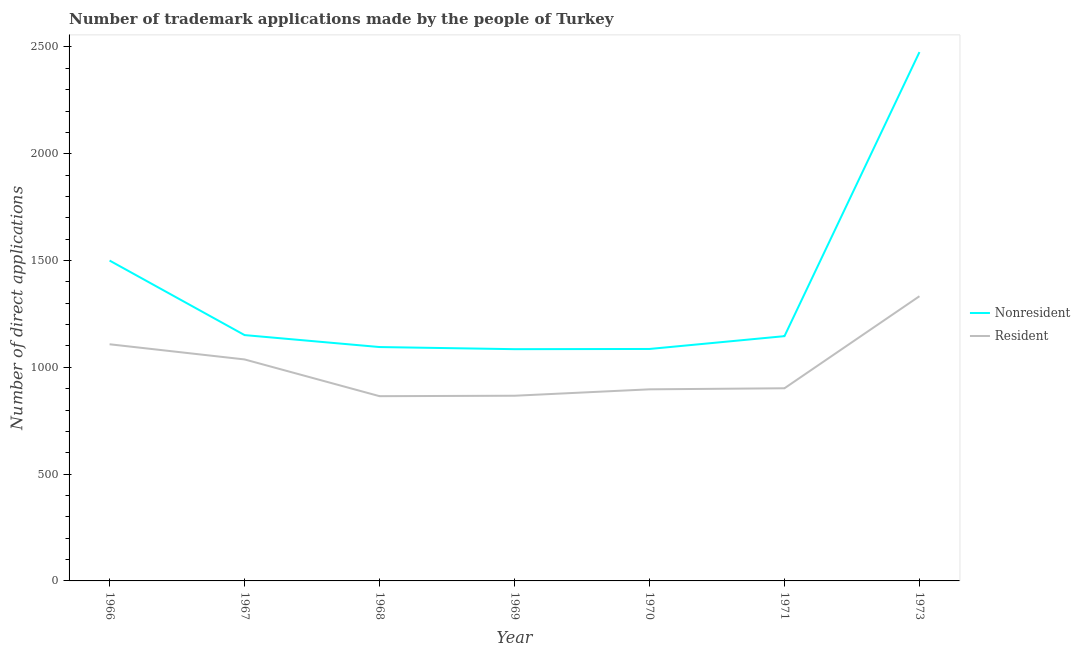How many different coloured lines are there?
Your response must be concise. 2. Does the line corresponding to number of trademark applications made by residents intersect with the line corresponding to number of trademark applications made by non residents?
Provide a succinct answer. No. What is the number of trademark applications made by residents in 1967?
Provide a short and direct response. 1037. Across all years, what is the maximum number of trademark applications made by non residents?
Keep it short and to the point. 2476. Across all years, what is the minimum number of trademark applications made by residents?
Offer a very short reply. 865. In which year was the number of trademark applications made by residents maximum?
Make the answer very short. 1973. In which year was the number of trademark applications made by non residents minimum?
Keep it short and to the point. 1969. What is the total number of trademark applications made by residents in the graph?
Make the answer very short. 7009. What is the difference between the number of trademark applications made by residents in 1967 and that in 1968?
Ensure brevity in your answer.  172. What is the difference between the number of trademark applications made by residents in 1967 and the number of trademark applications made by non residents in 1973?
Make the answer very short. -1439. What is the average number of trademark applications made by non residents per year?
Keep it short and to the point. 1362.71. In the year 1969, what is the difference between the number of trademark applications made by non residents and number of trademark applications made by residents?
Keep it short and to the point. 218. In how many years, is the number of trademark applications made by residents greater than 500?
Your answer should be compact. 7. What is the ratio of the number of trademark applications made by non residents in 1967 to that in 1973?
Give a very brief answer. 0.46. Is the number of trademark applications made by non residents in 1968 less than that in 1971?
Provide a short and direct response. Yes. What is the difference between the highest and the second highest number of trademark applications made by residents?
Offer a very short reply. 225. What is the difference between the highest and the lowest number of trademark applications made by non residents?
Offer a very short reply. 1391. In how many years, is the number of trademark applications made by residents greater than the average number of trademark applications made by residents taken over all years?
Provide a succinct answer. 3. Is the sum of the number of trademark applications made by residents in 1969 and 1973 greater than the maximum number of trademark applications made by non residents across all years?
Make the answer very short. No. Is the number of trademark applications made by residents strictly greater than the number of trademark applications made by non residents over the years?
Ensure brevity in your answer.  No. How many years are there in the graph?
Keep it short and to the point. 7. What is the difference between two consecutive major ticks on the Y-axis?
Keep it short and to the point. 500. Does the graph contain grids?
Your answer should be very brief. No. Where does the legend appear in the graph?
Your answer should be very brief. Center right. How many legend labels are there?
Offer a terse response. 2. How are the legend labels stacked?
Make the answer very short. Vertical. What is the title of the graph?
Your response must be concise. Number of trademark applications made by the people of Turkey. What is the label or title of the X-axis?
Provide a short and direct response. Year. What is the label or title of the Y-axis?
Offer a very short reply. Number of direct applications. What is the Number of direct applications of Nonresident in 1966?
Provide a succinct answer. 1500. What is the Number of direct applications of Resident in 1966?
Provide a short and direct response. 1108. What is the Number of direct applications of Nonresident in 1967?
Ensure brevity in your answer.  1151. What is the Number of direct applications of Resident in 1967?
Offer a very short reply. 1037. What is the Number of direct applications in Nonresident in 1968?
Provide a succinct answer. 1095. What is the Number of direct applications of Resident in 1968?
Offer a very short reply. 865. What is the Number of direct applications in Nonresident in 1969?
Offer a very short reply. 1085. What is the Number of direct applications of Resident in 1969?
Offer a terse response. 867. What is the Number of direct applications in Nonresident in 1970?
Offer a terse response. 1086. What is the Number of direct applications of Resident in 1970?
Make the answer very short. 897. What is the Number of direct applications in Nonresident in 1971?
Ensure brevity in your answer.  1146. What is the Number of direct applications in Resident in 1971?
Keep it short and to the point. 902. What is the Number of direct applications of Nonresident in 1973?
Provide a short and direct response. 2476. What is the Number of direct applications in Resident in 1973?
Offer a terse response. 1333. Across all years, what is the maximum Number of direct applications in Nonresident?
Provide a succinct answer. 2476. Across all years, what is the maximum Number of direct applications in Resident?
Provide a short and direct response. 1333. Across all years, what is the minimum Number of direct applications in Nonresident?
Your answer should be very brief. 1085. Across all years, what is the minimum Number of direct applications in Resident?
Offer a terse response. 865. What is the total Number of direct applications of Nonresident in the graph?
Provide a short and direct response. 9539. What is the total Number of direct applications of Resident in the graph?
Offer a very short reply. 7009. What is the difference between the Number of direct applications in Nonresident in 1966 and that in 1967?
Make the answer very short. 349. What is the difference between the Number of direct applications in Nonresident in 1966 and that in 1968?
Your answer should be compact. 405. What is the difference between the Number of direct applications in Resident in 1966 and that in 1968?
Keep it short and to the point. 243. What is the difference between the Number of direct applications of Nonresident in 1966 and that in 1969?
Offer a terse response. 415. What is the difference between the Number of direct applications in Resident in 1966 and that in 1969?
Provide a succinct answer. 241. What is the difference between the Number of direct applications of Nonresident in 1966 and that in 1970?
Offer a very short reply. 414. What is the difference between the Number of direct applications of Resident in 1966 and that in 1970?
Make the answer very short. 211. What is the difference between the Number of direct applications of Nonresident in 1966 and that in 1971?
Ensure brevity in your answer.  354. What is the difference between the Number of direct applications in Resident in 1966 and that in 1971?
Your response must be concise. 206. What is the difference between the Number of direct applications of Nonresident in 1966 and that in 1973?
Provide a short and direct response. -976. What is the difference between the Number of direct applications of Resident in 1966 and that in 1973?
Keep it short and to the point. -225. What is the difference between the Number of direct applications in Nonresident in 1967 and that in 1968?
Offer a terse response. 56. What is the difference between the Number of direct applications in Resident in 1967 and that in 1968?
Offer a very short reply. 172. What is the difference between the Number of direct applications of Nonresident in 1967 and that in 1969?
Keep it short and to the point. 66. What is the difference between the Number of direct applications in Resident in 1967 and that in 1969?
Offer a very short reply. 170. What is the difference between the Number of direct applications of Resident in 1967 and that in 1970?
Offer a terse response. 140. What is the difference between the Number of direct applications of Nonresident in 1967 and that in 1971?
Provide a succinct answer. 5. What is the difference between the Number of direct applications of Resident in 1967 and that in 1971?
Make the answer very short. 135. What is the difference between the Number of direct applications in Nonresident in 1967 and that in 1973?
Your response must be concise. -1325. What is the difference between the Number of direct applications of Resident in 1967 and that in 1973?
Provide a succinct answer. -296. What is the difference between the Number of direct applications in Nonresident in 1968 and that in 1970?
Ensure brevity in your answer.  9. What is the difference between the Number of direct applications of Resident in 1968 and that in 1970?
Your answer should be very brief. -32. What is the difference between the Number of direct applications of Nonresident in 1968 and that in 1971?
Give a very brief answer. -51. What is the difference between the Number of direct applications of Resident in 1968 and that in 1971?
Ensure brevity in your answer.  -37. What is the difference between the Number of direct applications of Nonresident in 1968 and that in 1973?
Ensure brevity in your answer.  -1381. What is the difference between the Number of direct applications of Resident in 1968 and that in 1973?
Provide a succinct answer. -468. What is the difference between the Number of direct applications in Resident in 1969 and that in 1970?
Your response must be concise. -30. What is the difference between the Number of direct applications of Nonresident in 1969 and that in 1971?
Give a very brief answer. -61. What is the difference between the Number of direct applications of Resident in 1969 and that in 1971?
Ensure brevity in your answer.  -35. What is the difference between the Number of direct applications in Nonresident in 1969 and that in 1973?
Make the answer very short. -1391. What is the difference between the Number of direct applications of Resident in 1969 and that in 1973?
Provide a succinct answer. -466. What is the difference between the Number of direct applications in Nonresident in 1970 and that in 1971?
Offer a terse response. -60. What is the difference between the Number of direct applications in Resident in 1970 and that in 1971?
Ensure brevity in your answer.  -5. What is the difference between the Number of direct applications of Nonresident in 1970 and that in 1973?
Provide a succinct answer. -1390. What is the difference between the Number of direct applications of Resident in 1970 and that in 1973?
Your response must be concise. -436. What is the difference between the Number of direct applications in Nonresident in 1971 and that in 1973?
Provide a succinct answer. -1330. What is the difference between the Number of direct applications in Resident in 1971 and that in 1973?
Offer a very short reply. -431. What is the difference between the Number of direct applications of Nonresident in 1966 and the Number of direct applications of Resident in 1967?
Offer a terse response. 463. What is the difference between the Number of direct applications in Nonresident in 1966 and the Number of direct applications in Resident in 1968?
Offer a terse response. 635. What is the difference between the Number of direct applications of Nonresident in 1966 and the Number of direct applications of Resident in 1969?
Provide a succinct answer. 633. What is the difference between the Number of direct applications in Nonresident in 1966 and the Number of direct applications in Resident in 1970?
Your answer should be compact. 603. What is the difference between the Number of direct applications of Nonresident in 1966 and the Number of direct applications of Resident in 1971?
Offer a very short reply. 598. What is the difference between the Number of direct applications in Nonresident in 1966 and the Number of direct applications in Resident in 1973?
Your answer should be very brief. 167. What is the difference between the Number of direct applications of Nonresident in 1967 and the Number of direct applications of Resident in 1968?
Make the answer very short. 286. What is the difference between the Number of direct applications in Nonresident in 1967 and the Number of direct applications in Resident in 1969?
Keep it short and to the point. 284. What is the difference between the Number of direct applications in Nonresident in 1967 and the Number of direct applications in Resident in 1970?
Ensure brevity in your answer.  254. What is the difference between the Number of direct applications in Nonresident in 1967 and the Number of direct applications in Resident in 1971?
Offer a very short reply. 249. What is the difference between the Number of direct applications of Nonresident in 1967 and the Number of direct applications of Resident in 1973?
Offer a terse response. -182. What is the difference between the Number of direct applications in Nonresident in 1968 and the Number of direct applications in Resident in 1969?
Your answer should be compact. 228. What is the difference between the Number of direct applications in Nonresident in 1968 and the Number of direct applications in Resident in 1970?
Give a very brief answer. 198. What is the difference between the Number of direct applications of Nonresident in 1968 and the Number of direct applications of Resident in 1971?
Provide a short and direct response. 193. What is the difference between the Number of direct applications in Nonresident in 1968 and the Number of direct applications in Resident in 1973?
Offer a very short reply. -238. What is the difference between the Number of direct applications in Nonresident in 1969 and the Number of direct applications in Resident in 1970?
Give a very brief answer. 188. What is the difference between the Number of direct applications in Nonresident in 1969 and the Number of direct applications in Resident in 1971?
Give a very brief answer. 183. What is the difference between the Number of direct applications of Nonresident in 1969 and the Number of direct applications of Resident in 1973?
Your answer should be compact. -248. What is the difference between the Number of direct applications of Nonresident in 1970 and the Number of direct applications of Resident in 1971?
Offer a terse response. 184. What is the difference between the Number of direct applications of Nonresident in 1970 and the Number of direct applications of Resident in 1973?
Offer a very short reply. -247. What is the difference between the Number of direct applications of Nonresident in 1971 and the Number of direct applications of Resident in 1973?
Provide a short and direct response. -187. What is the average Number of direct applications in Nonresident per year?
Your response must be concise. 1362.71. What is the average Number of direct applications of Resident per year?
Your answer should be very brief. 1001.29. In the year 1966, what is the difference between the Number of direct applications in Nonresident and Number of direct applications in Resident?
Keep it short and to the point. 392. In the year 1967, what is the difference between the Number of direct applications of Nonresident and Number of direct applications of Resident?
Ensure brevity in your answer.  114. In the year 1968, what is the difference between the Number of direct applications in Nonresident and Number of direct applications in Resident?
Give a very brief answer. 230. In the year 1969, what is the difference between the Number of direct applications of Nonresident and Number of direct applications of Resident?
Provide a succinct answer. 218. In the year 1970, what is the difference between the Number of direct applications of Nonresident and Number of direct applications of Resident?
Your response must be concise. 189. In the year 1971, what is the difference between the Number of direct applications of Nonresident and Number of direct applications of Resident?
Offer a terse response. 244. In the year 1973, what is the difference between the Number of direct applications in Nonresident and Number of direct applications in Resident?
Make the answer very short. 1143. What is the ratio of the Number of direct applications in Nonresident in 1966 to that in 1967?
Provide a short and direct response. 1.3. What is the ratio of the Number of direct applications in Resident in 1966 to that in 1967?
Provide a succinct answer. 1.07. What is the ratio of the Number of direct applications of Nonresident in 1966 to that in 1968?
Offer a very short reply. 1.37. What is the ratio of the Number of direct applications of Resident in 1966 to that in 1968?
Provide a short and direct response. 1.28. What is the ratio of the Number of direct applications in Nonresident in 1966 to that in 1969?
Your answer should be compact. 1.38. What is the ratio of the Number of direct applications in Resident in 1966 to that in 1969?
Provide a succinct answer. 1.28. What is the ratio of the Number of direct applications in Nonresident in 1966 to that in 1970?
Keep it short and to the point. 1.38. What is the ratio of the Number of direct applications in Resident in 1966 to that in 1970?
Offer a terse response. 1.24. What is the ratio of the Number of direct applications of Nonresident in 1966 to that in 1971?
Your answer should be very brief. 1.31. What is the ratio of the Number of direct applications of Resident in 1966 to that in 1971?
Your response must be concise. 1.23. What is the ratio of the Number of direct applications of Nonresident in 1966 to that in 1973?
Your answer should be compact. 0.61. What is the ratio of the Number of direct applications in Resident in 1966 to that in 1973?
Offer a very short reply. 0.83. What is the ratio of the Number of direct applications in Nonresident in 1967 to that in 1968?
Your answer should be compact. 1.05. What is the ratio of the Number of direct applications of Resident in 1967 to that in 1968?
Provide a succinct answer. 1.2. What is the ratio of the Number of direct applications of Nonresident in 1967 to that in 1969?
Give a very brief answer. 1.06. What is the ratio of the Number of direct applications in Resident in 1967 to that in 1969?
Keep it short and to the point. 1.2. What is the ratio of the Number of direct applications of Nonresident in 1967 to that in 1970?
Ensure brevity in your answer.  1.06. What is the ratio of the Number of direct applications of Resident in 1967 to that in 1970?
Provide a short and direct response. 1.16. What is the ratio of the Number of direct applications in Resident in 1967 to that in 1971?
Make the answer very short. 1.15. What is the ratio of the Number of direct applications of Nonresident in 1967 to that in 1973?
Offer a terse response. 0.46. What is the ratio of the Number of direct applications of Resident in 1967 to that in 1973?
Your answer should be compact. 0.78. What is the ratio of the Number of direct applications in Nonresident in 1968 to that in 1969?
Offer a very short reply. 1.01. What is the ratio of the Number of direct applications of Nonresident in 1968 to that in 1970?
Offer a very short reply. 1.01. What is the ratio of the Number of direct applications in Resident in 1968 to that in 1970?
Your response must be concise. 0.96. What is the ratio of the Number of direct applications of Nonresident in 1968 to that in 1971?
Offer a very short reply. 0.96. What is the ratio of the Number of direct applications in Resident in 1968 to that in 1971?
Offer a very short reply. 0.96. What is the ratio of the Number of direct applications of Nonresident in 1968 to that in 1973?
Offer a very short reply. 0.44. What is the ratio of the Number of direct applications of Resident in 1968 to that in 1973?
Your response must be concise. 0.65. What is the ratio of the Number of direct applications in Resident in 1969 to that in 1970?
Give a very brief answer. 0.97. What is the ratio of the Number of direct applications of Nonresident in 1969 to that in 1971?
Offer a terse response. 0.95. What is the ratio of the Number of direct applications of Resident in 1969 to that in 1971?
Offer a very short reply. 0.96. What is the ratio of the Number of direct applications of Nonresident in 1969 to that in 1973?
Ensure brevity in your answer.  0.44. What is the ratio of the Number of direct applications in Resident in 1969 to that in 1973?
Make the answer very short. 0.65. What is the ratio of the Number of direct applications of Nonresident in 1970 to that in 1971?
Ensure brevity in your answer.  0.95. What is the ratio of the Number of direct applications of Nonresident in 1970 to that in 1973?
Give a very brief answer. 0.44. What is the ratio of the Number of direct applications of Resident in 1970 to that in 1973?
Give a very brief answer. 0.67. What is the ratio of the Number of direct applications in Nonresident in 1971 to that in 1973?
Offer a very short reply. 0.46. What is the ratio of the Number of direct applications in Resident in 1971 to that in 1973?
Provide a succinct answer. 0.68. What is the difference between the highest and the second highest Number of direct applications in Nonresident?
Your answer should be compact. 976. What is the difference between the highest and the second highest Number of direct applications in Resident?
Your answer should be compact. 225. What is the difference between the highest and the lowest Number of direct applications of Nonresident?
Ensure brevity in your answer.  1391. What is the difference between the highest and the lowest Number of direct applications of Resident?
Offer a very short reply. 468. 